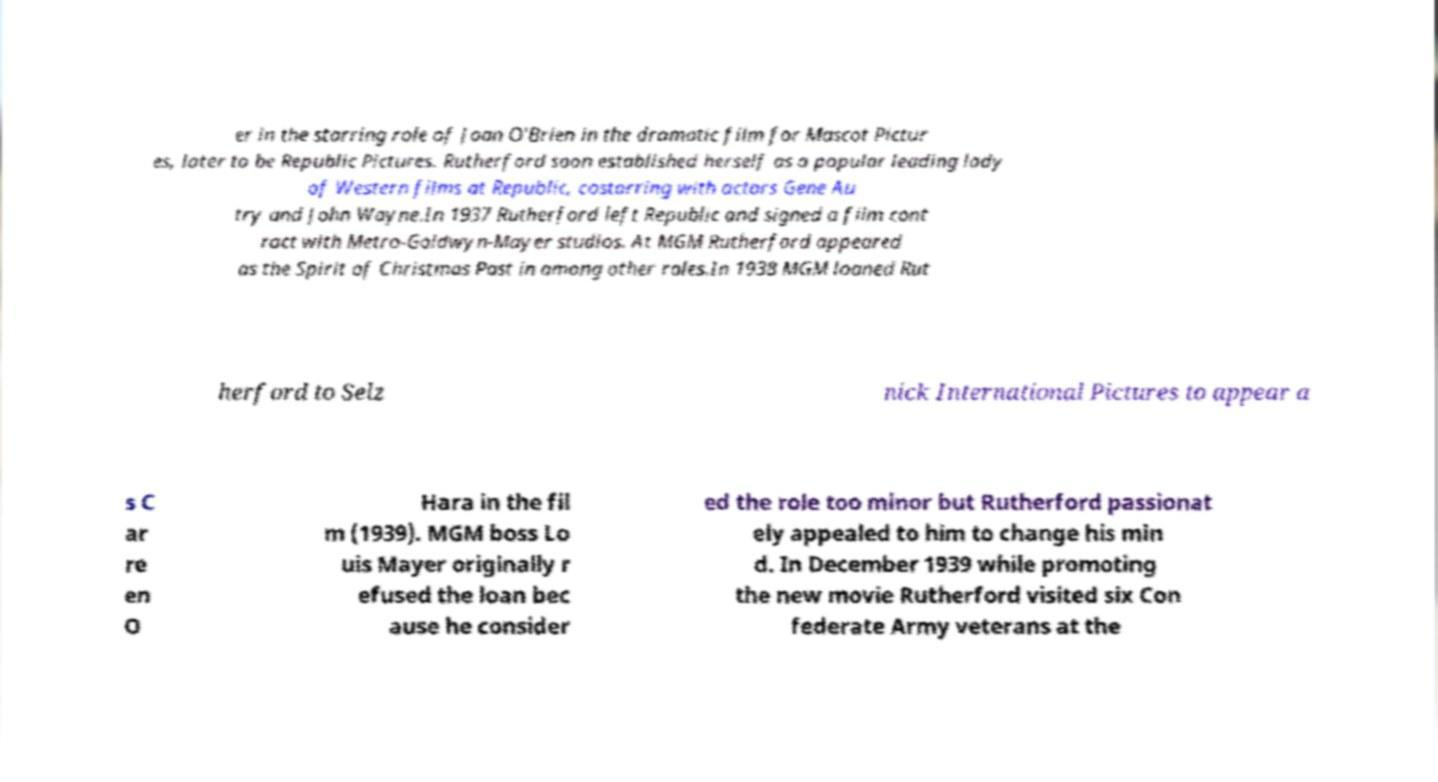Could you extract and type out the text from this image? er in the starring role of Joan O'Brien in the dramatic film for Mascot Pictur es, later to be Republic Pictures. Rutherford soon established herself as a popular leading lady of Western films at Republic, costarring with actors Gene Au try and John Wayne.In 1937 Rutherford left Republic and signed a film cont ract with Metro-Goldwyn-Mayer studios. At MGM Rutherford appeared as the Spirit of Christmas Past in among other roles.In 1938 MGM loaned Rut herford to Selz nick International Pictures to appear a s C ar re en O Hara in the fil m (1939). MGM boss Lo uis Mayer originally r efused the loan bec ause he consider ed the role too minor but Rutherford passionat ely appealed to him to change his min d. In December 1939 while promoting the new movie Rutherford visited six Con federate Army veterans at the 